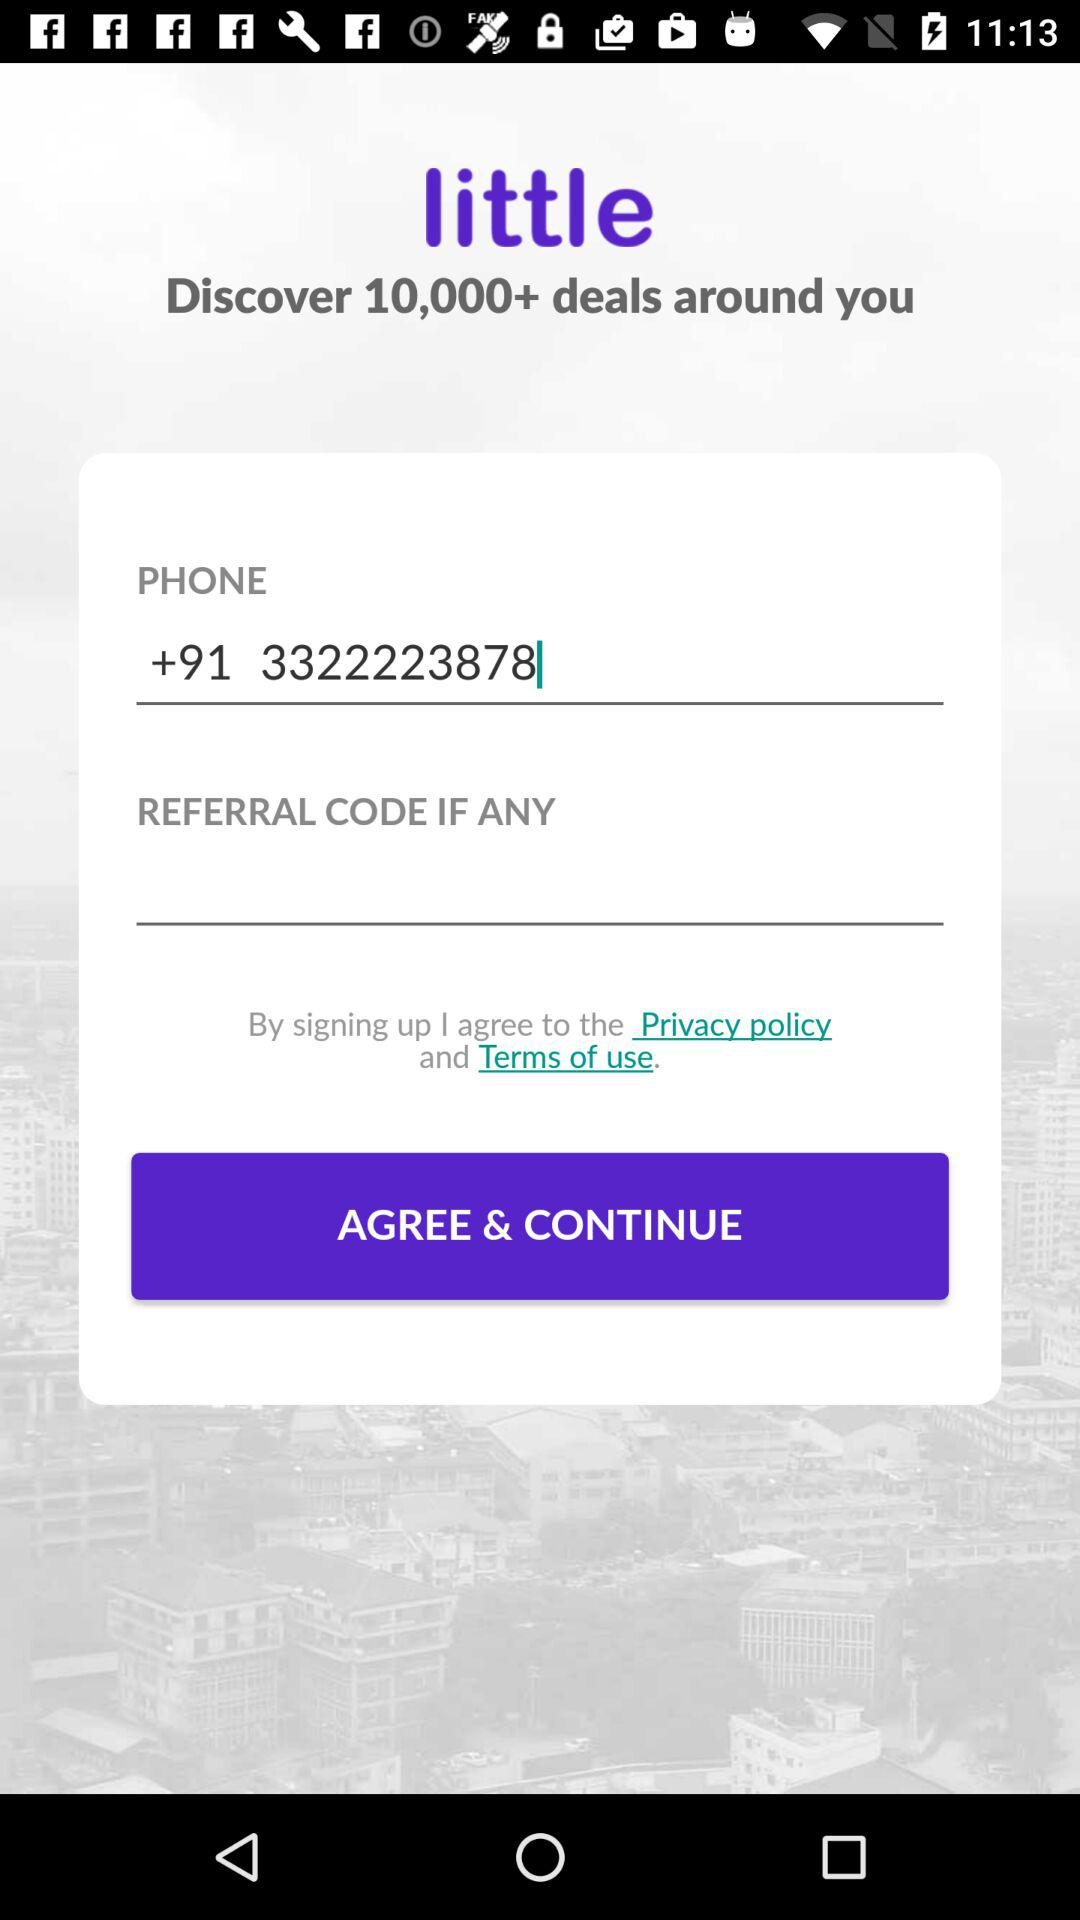What is the phone number? The phone number is +91 3322223878. 